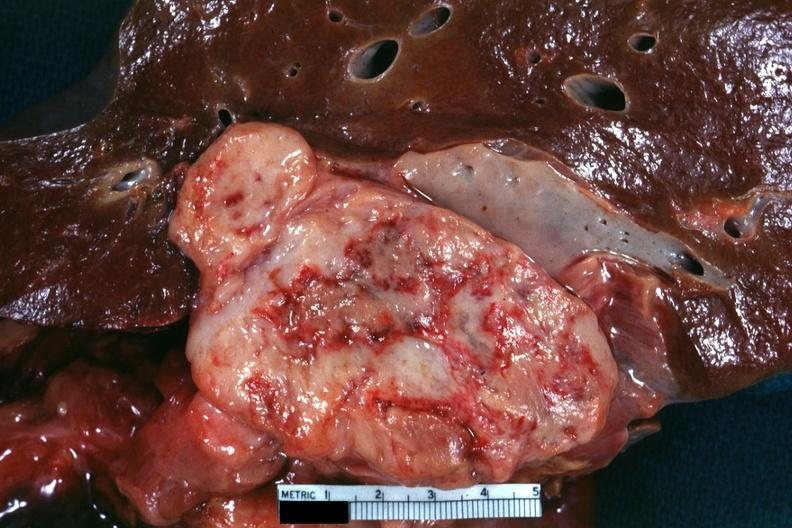what is present?
Answer the question using a single word or phrase. Abdomen 